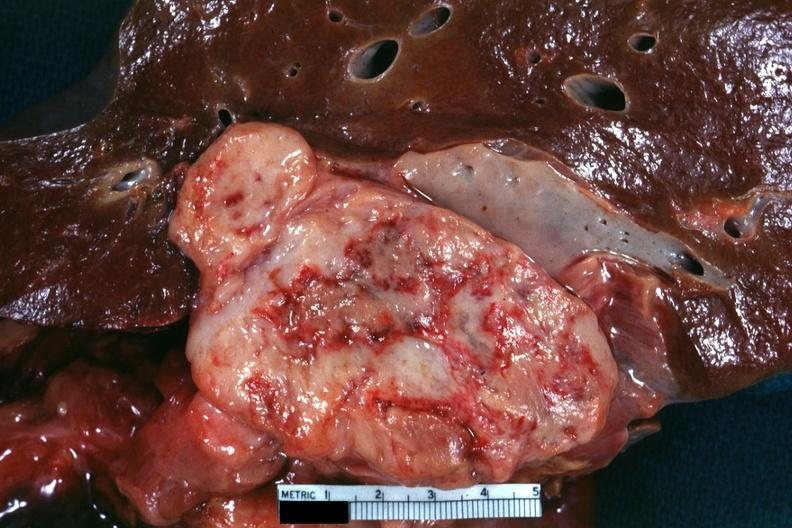what is present?
Answer the question using a single word or phrase. Abdomen 